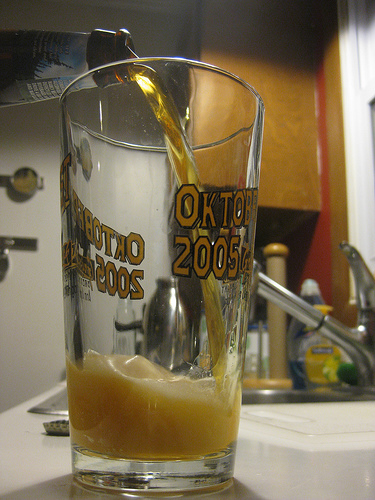<image>
Can you confirm if the bottle cap is on the bottle? No. The bottle cap is not positioned on the bottle. They may be near each other, but the bottle cap is not supported by or resting on top of the bottle. 